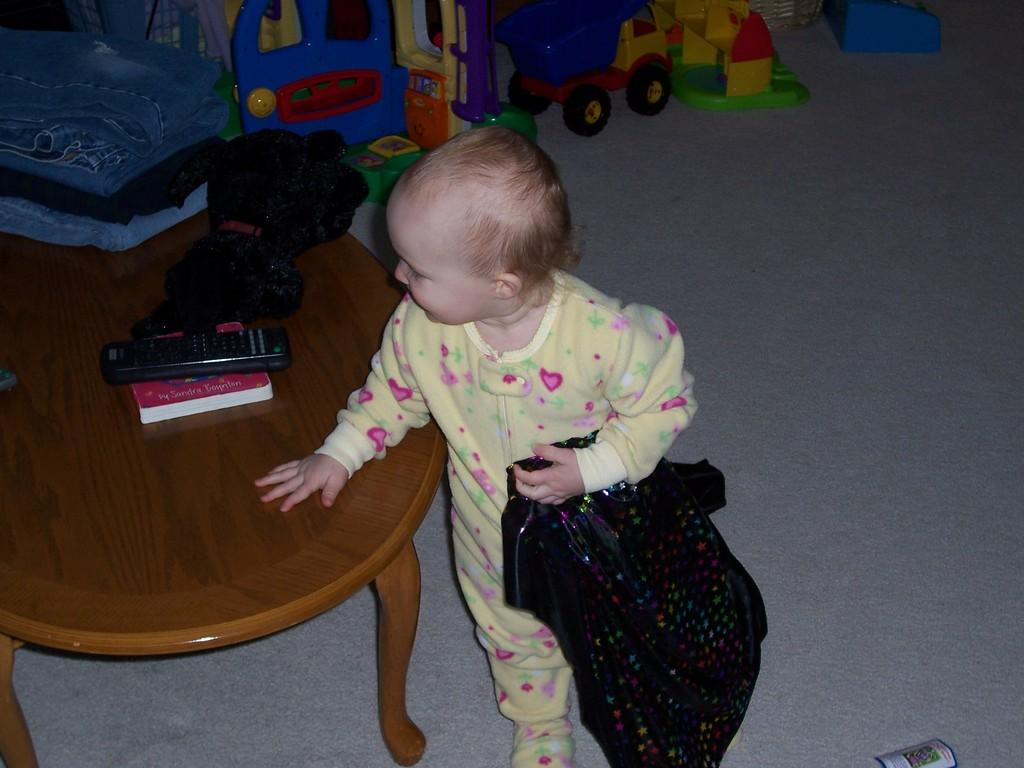Who is the main subject in the image? There is a little girl in the image. What is the girl wearing? The girl is wearing a yellow dress. Where is the girl standing in relation to the table? The girl is standing in front of a table. What items can be seen on the table? There are pants, a doll, a remote, and a book on the table. What else can be seen in the image besides the girl and the table? There are toys visible behind the girl. What type of religious ceremony is taking place in the image? There is no indication of a religious ceremony in the image; it features a little girl standing in front of a table with various items. What punishment is being administered to the girl in the image? There is no punishment being administered to the girl in the image; she is simply standing in front of a table with various items. 